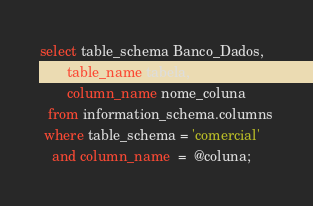<code> <loc_0><loc_0><loc_500><loc_500><_SQL_>

select table_schema Banco_Dados, 
       table_name tabela, 
	   column_name nome_coluna
  from information_schema.columns
 where table_schema = 'comercial'
   and column_name  =  @coluna;</code> 